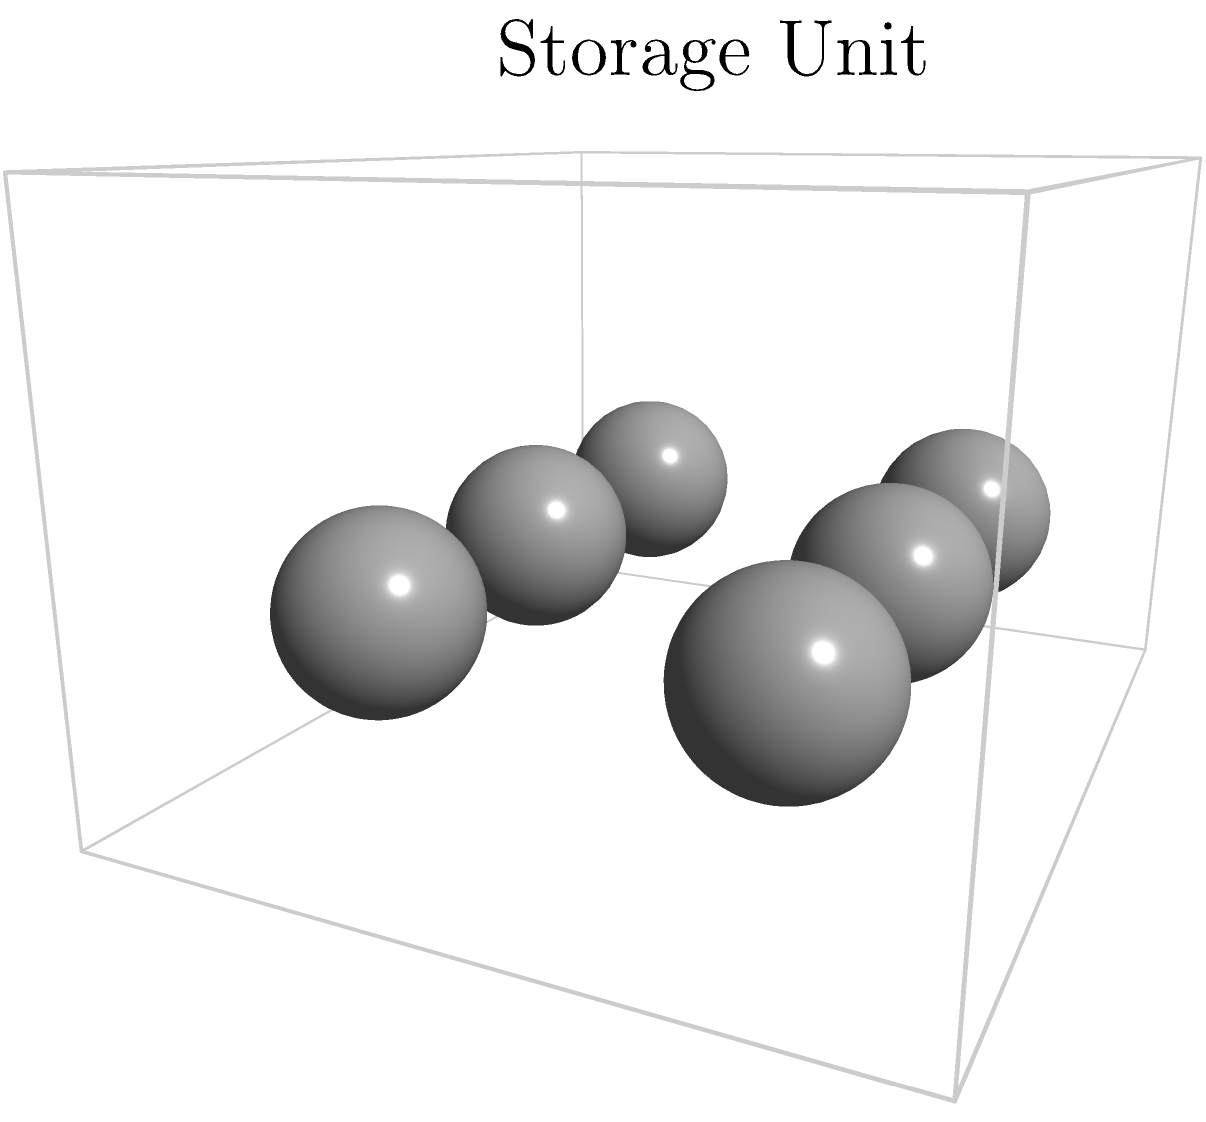In a police equipment storage unit, there are 6 identical spherical tear gas canisters, each with a radius of 10 cm. Calculate the total volume of tear gas that can be stored in these canisters, rounded to the nearest liter. To solve this problem, we'll follow these steps:

1. Calculate the volume of a single spherical canister:
   The formula for the volume of a sphere is $V = \frac{4}{3}\pi r^3$

   $V = \frac{4}{3} \pi (10\text{ cm})^3$
   $V = \frac{4}{3} \pi (1000\text{ cm}^3)$
   $V = 4188.79\text{ cm}^3$

2. Multiply the volume of one canister by the total number of canisters:
   Total volume $= 6 \times 4188.79\text{ cm}^3 = 25132.74\text{ cm}^3$

3. Convert cubic centimeters to liters:
   $1\text{ L} = 1000\text{ cm}^3$
   $25132.74\text{ cm}^3 = 25.13274\text{ L}$

4. Round to the nearest liter:
   $25.13274\text{ L} \approx 25\text{ L}$

Therefore, the total volume of tear gas that can be stored in these canisters is approximately 25 liters.
Answer: 25 L 